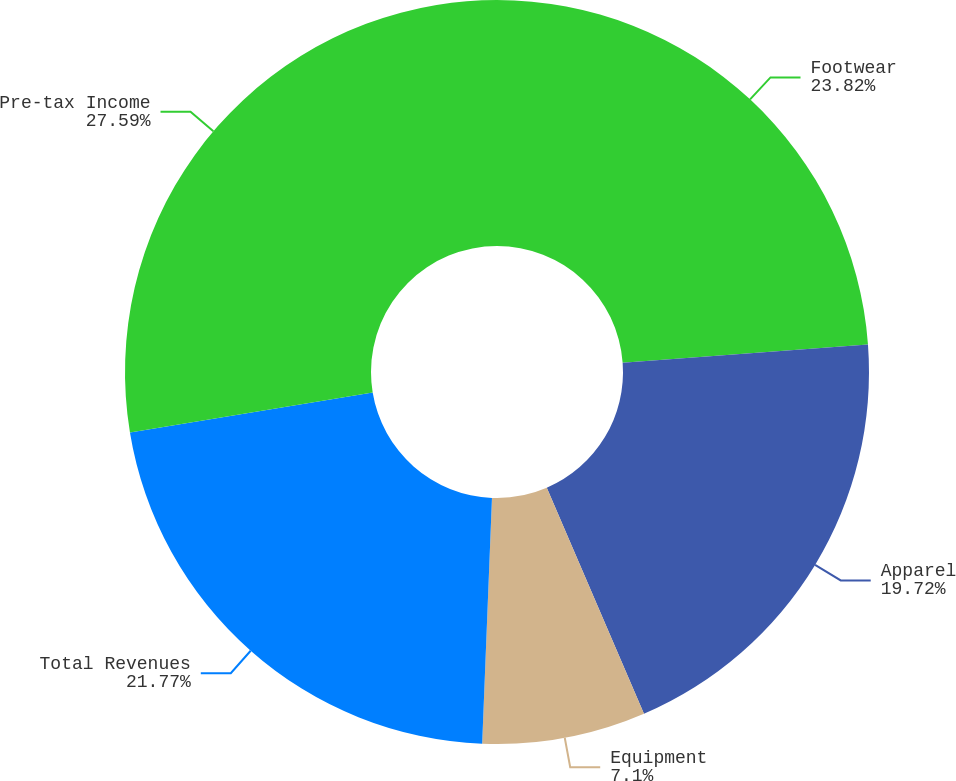Convert chart. <chart><loc_0><loc_0><loc_500><loc_500><pie_chart><fcel>Footwear<fcel>Apparel<fcel>Equipment<fcel>Total Revenues<fcel>Pre-tax Income<nl><fcel>23.82%<fcel>19.72%<fcel>7.1%<fcel>21.77%<fcel>27.6%<nl></chart> 